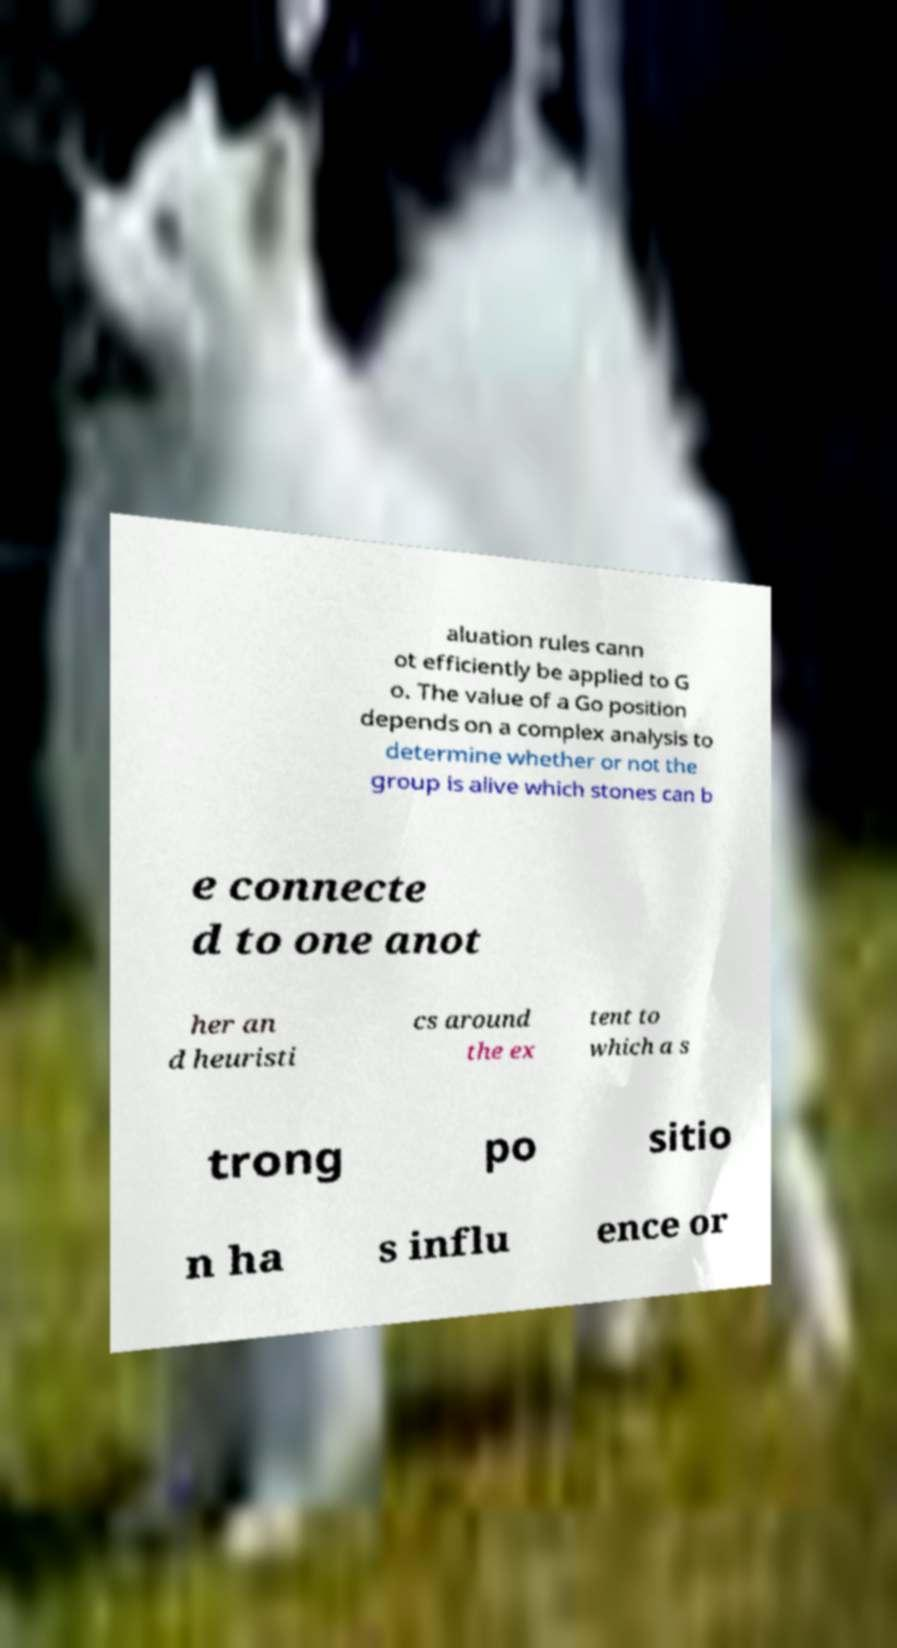There's text embedded in this image that I need extracted. Can you transcribe it verbatim? aluation rules cann ot efficiently be applied to G o. The value of a Go position depends on a complex analysis to determine whether or not the group is alive which stones can b e connecte d to one anot her an d heuristi cs around the ex tent to which a s trong po sitio n ha s influ ence or 